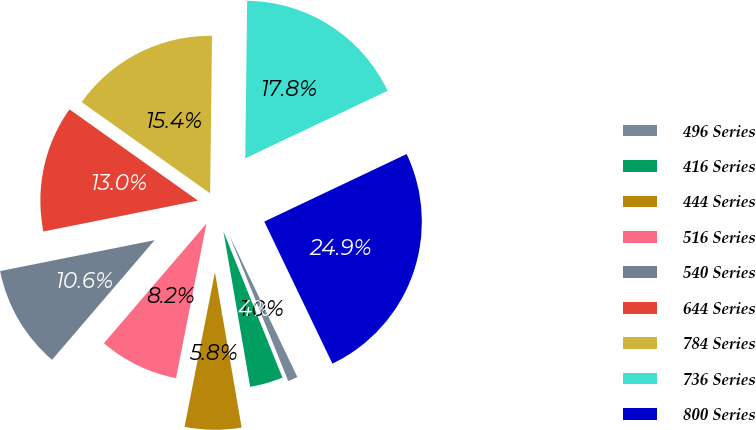<chart> <loc_0><loc_0><loc_500><loc_500><pie_chart><fcel>496 Series<fcel>416 Series<fcel>444 Series<fcel>516 Series<fcel>540 Series<fcel>644 Series<fcel>784 Series<fcel>736 Series<fcel>800 Series<nl><fcel>1.01%<fcel>3.4%<fcel>5.8%<fcel>8.19%<fcel>10.58%<fcel>12.97%<fcel>15.36%<fcel>17.76%<fcel>24.93%<nl></chart> 